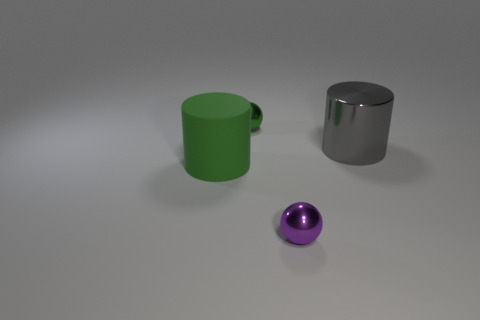Add 4 tiny green metal cylinders. How many objects exist? 8 Subtract 0 cyan cylinders. How many objects are left? 4 Subtract all blue metallic objects. Subtract all small purple metal things. How many objects are left? 3 Add 1 big rubber things. How many big rubber things are left? 2 Add 1 large gray cylinders. How many large gray cylinders exist? 2 